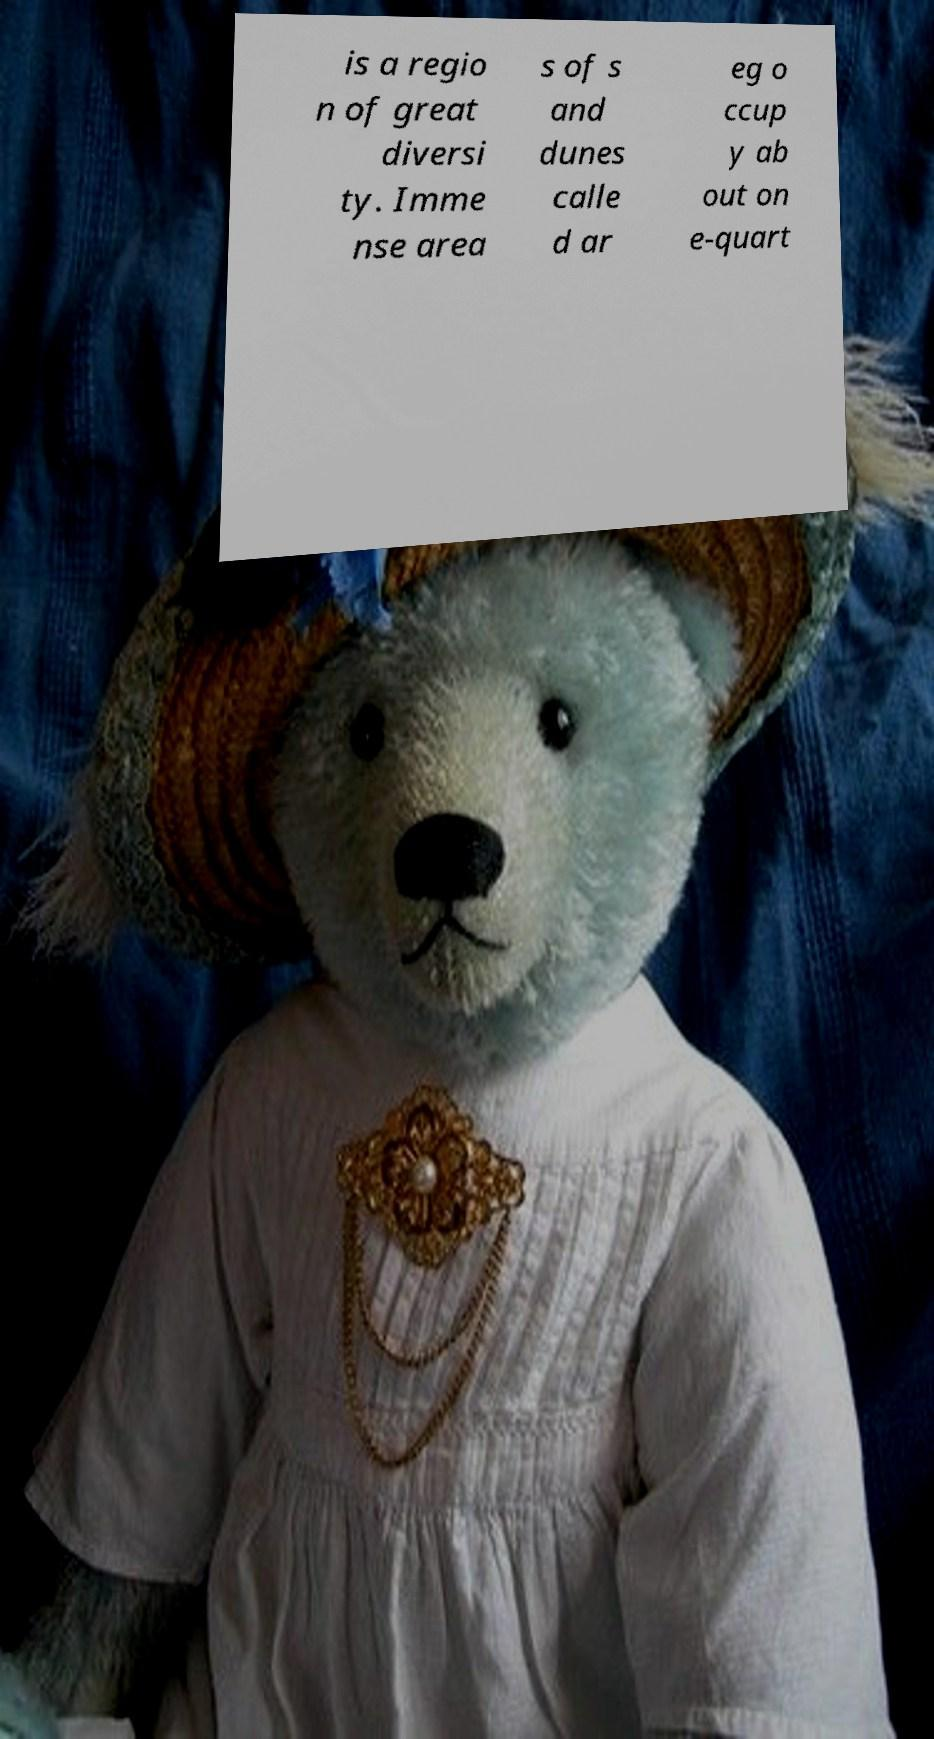Can you read and provide the text displayed in the image?This photo seems to have some interesting text. Can you extract and type it out for me? is a regio n of great diversi ty. Imme nse area s of s and dunes calle d ar eg o ccup y ab out on e-quart 